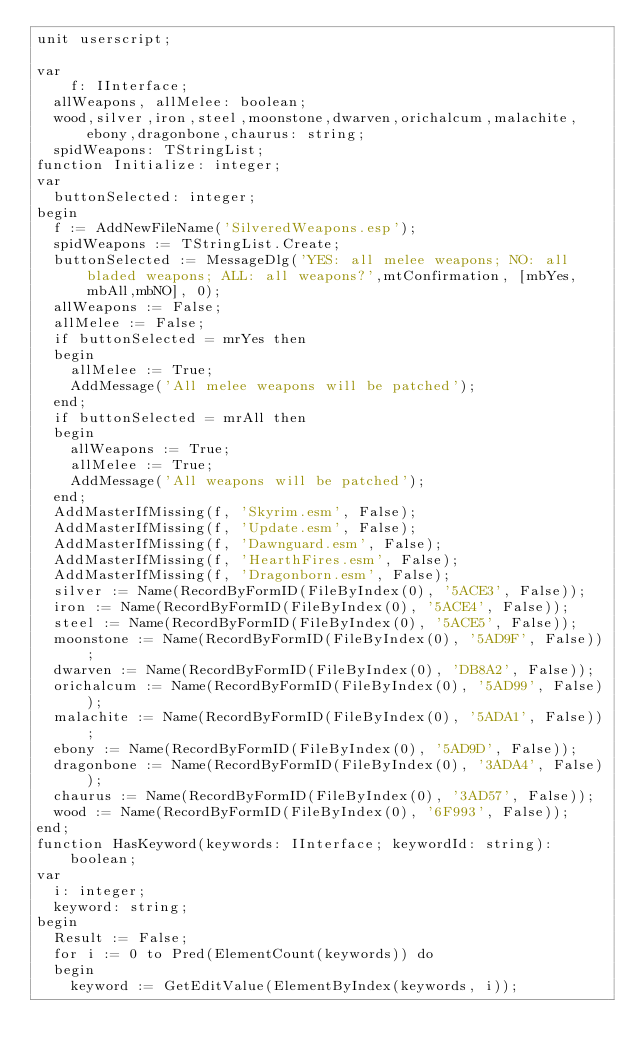<code> <loc_0><loc_0><loc_500><loc_500><_Pascal_>unit userscript;

var
	f: IInterface;
  allWeapons, allMelee: boolean;
  wood,silver,iron,steel,moonstone,dwarven,orichalcum,malachite,ebony,dragonbone,chaurus: string;
  spidWeapons: TStringList;
function Initialize: integer;
var
  buttonSelected: integer;
begin
  f := AddNewFileName('SilveredWeapons.esp');
  spidWeapons := TStringList.Create;
  buttonSelected := MessageDlg('YES: all melee weapons; NO: all bladed weapons; ALL: all weapons?',mtConfirmation, [mbYes,mbAll,mbNO], 0);
  allWeapons := False;
  allMelee := False;
  if buttonSelected = mrYes then
  begin
    allMelee := True;
    AddMessage('All melee weapons will be patched');
  end;
  if buttonSelected = mrAll then
  begin
    allWeapons := True;
    allMelee := True;
    AddMessage('All weapons will be patched');
  end;
  AddMasterIfMissing(f, 'Skyrim.esm', False);
  AddMasterIfMissing(f, 'Update.esm', False);
  AddMasterIfMissing(f, 'Dawnguard.esm', False);
  AddMasterIfMissing(f, 'HearthFires.esm', False);
  AddMasterIfMissing(f, 'Dragonborn.esm', False);
  silver := Name(RecordByFormID(FileByIndex(0), '5ACE3', False));
  iron := Name(RecordByFormID(FileByIndex(0), '5ACE4', False));
  steel := Name(RecordByFormID(FileByIndex(0), '5ACE5', False));
  moonstone := Name(RecordByFormID(FileByIndex(0), '5AD9F', False));
  dwarven := Name(RecordByFormID(FileByIndex(0), 'DB8A2', False));
  orichalcum := Name(RecordByFormID(FileByIndex(0), '5AD99', False));
  malachite := Name(RecordByFormID(FileByIndex(0), '5ADA1', False));
  ebony := Name(RecordByFormID(FileByIndex(0), '5AD9D', False));
  dragonbone := Name(RecordByFormID(FileByIndex(0), '3ADA4', False));
  chaurus := Name(RecordByFormID(FileByIndex(0), '3AD57', False));
  wood := Name(RecordByFormID(FileByIndex(0), '6F993', False));
end;
function HasKeyword(keywords: IInterface; keywordId: string): boolean;
var
  i: integer;
  keyword: string;
begin
  Result := False;
  for i := 0 to Pred(ElementCount(keywords)) do
  begin
    keyword := GetEditValue(ElementByIndex(keywords, i));</code> 